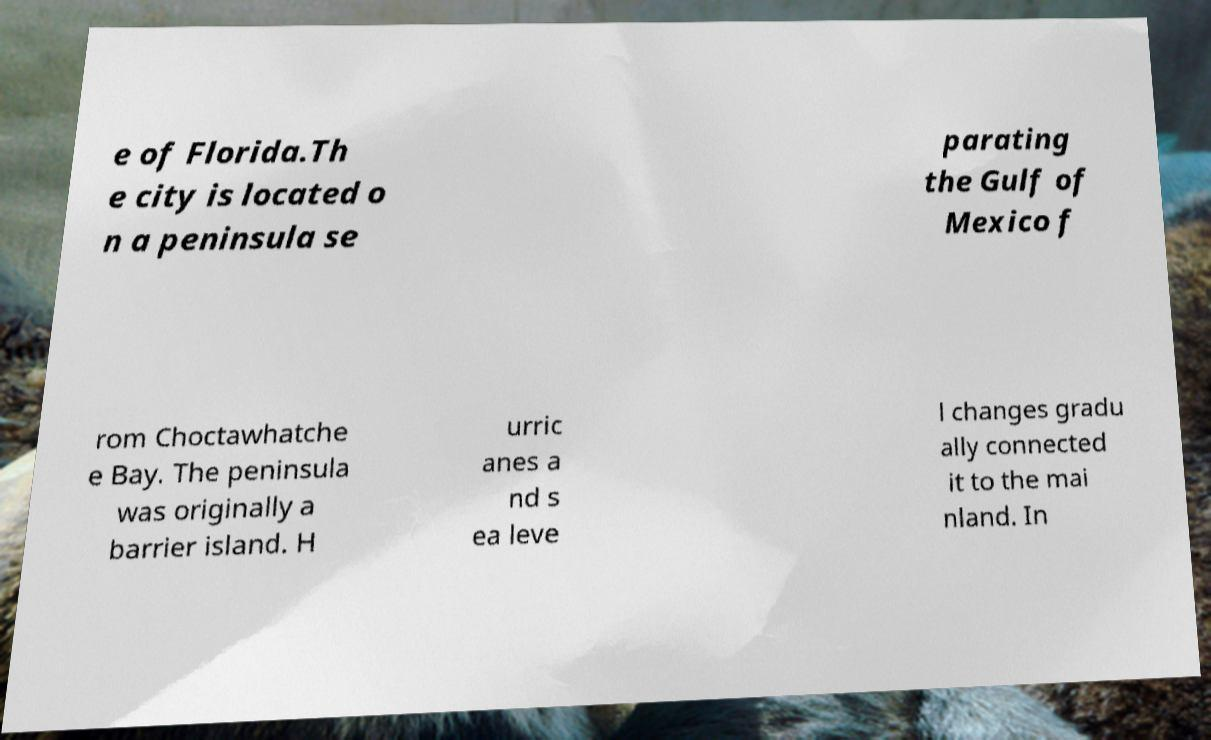Can you accurately transcribe the text from the provided image for me? e of Florida.Th e city is located o n a peninsula se parating the Gulf of Mexico f rom Choctawhatche e Bay. The peninsula was originally a barrier island. H urric anes a nd s ea leve l changes gradu ally connected it to the mai nland. In 